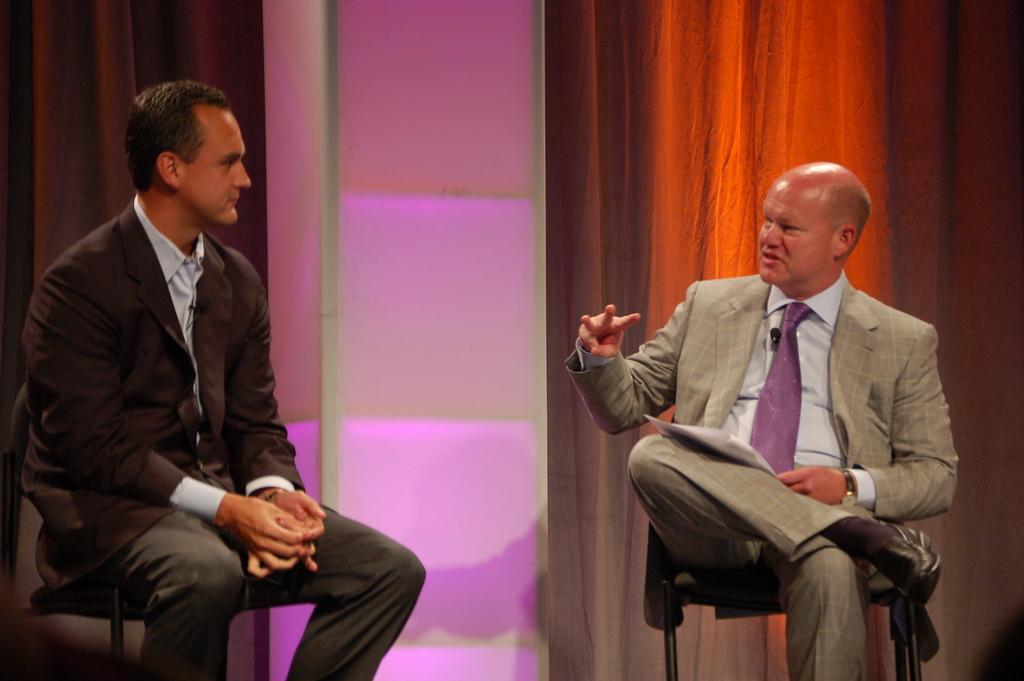How many people are in the image? There are two men in the image. What are the men wearing? The men are wearing suits. What are the men doing in the image? The men are sitting on chairs and talking. What can be seen in the background of the image? There is a wall in the background of the image, with lights and curtains on it. What type of stew is being served at the table in the image? There is no table or stew present in the image; it features two men sitting on chairs and talking. How does the digestion process of the men in the image appear to be going? There is no information about the men's digestion process in the image, as it focuses on their clothing and conversation. 